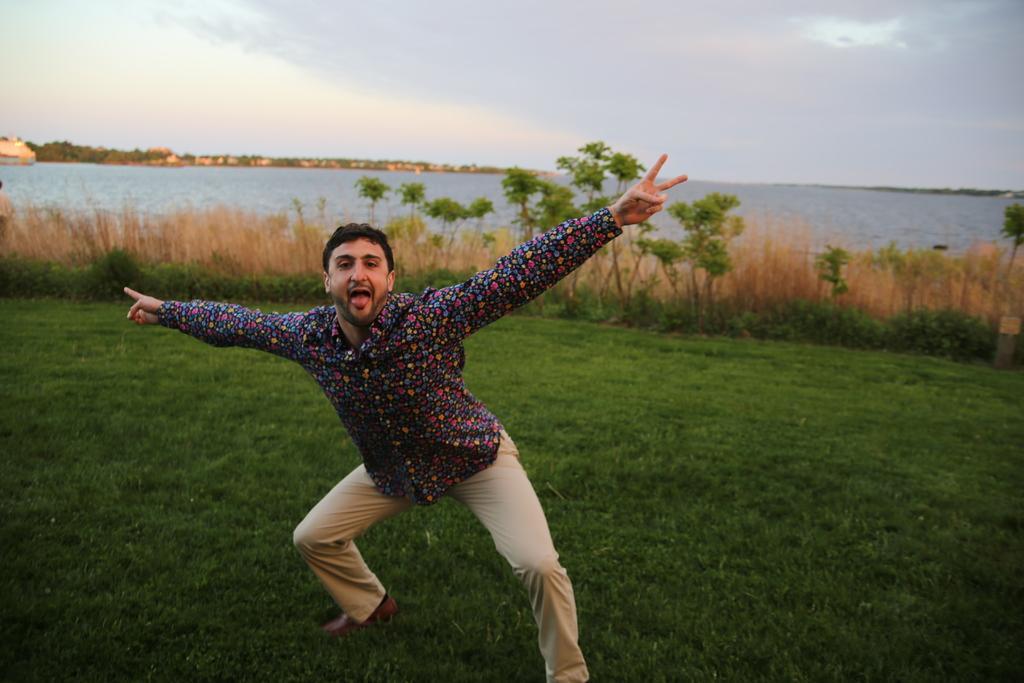Please provide a concise description of this image. In this picture I can see there is a man standing here on the grass, there are plants and trees. There is a ocean here and there are mountains and the sky is clear. 